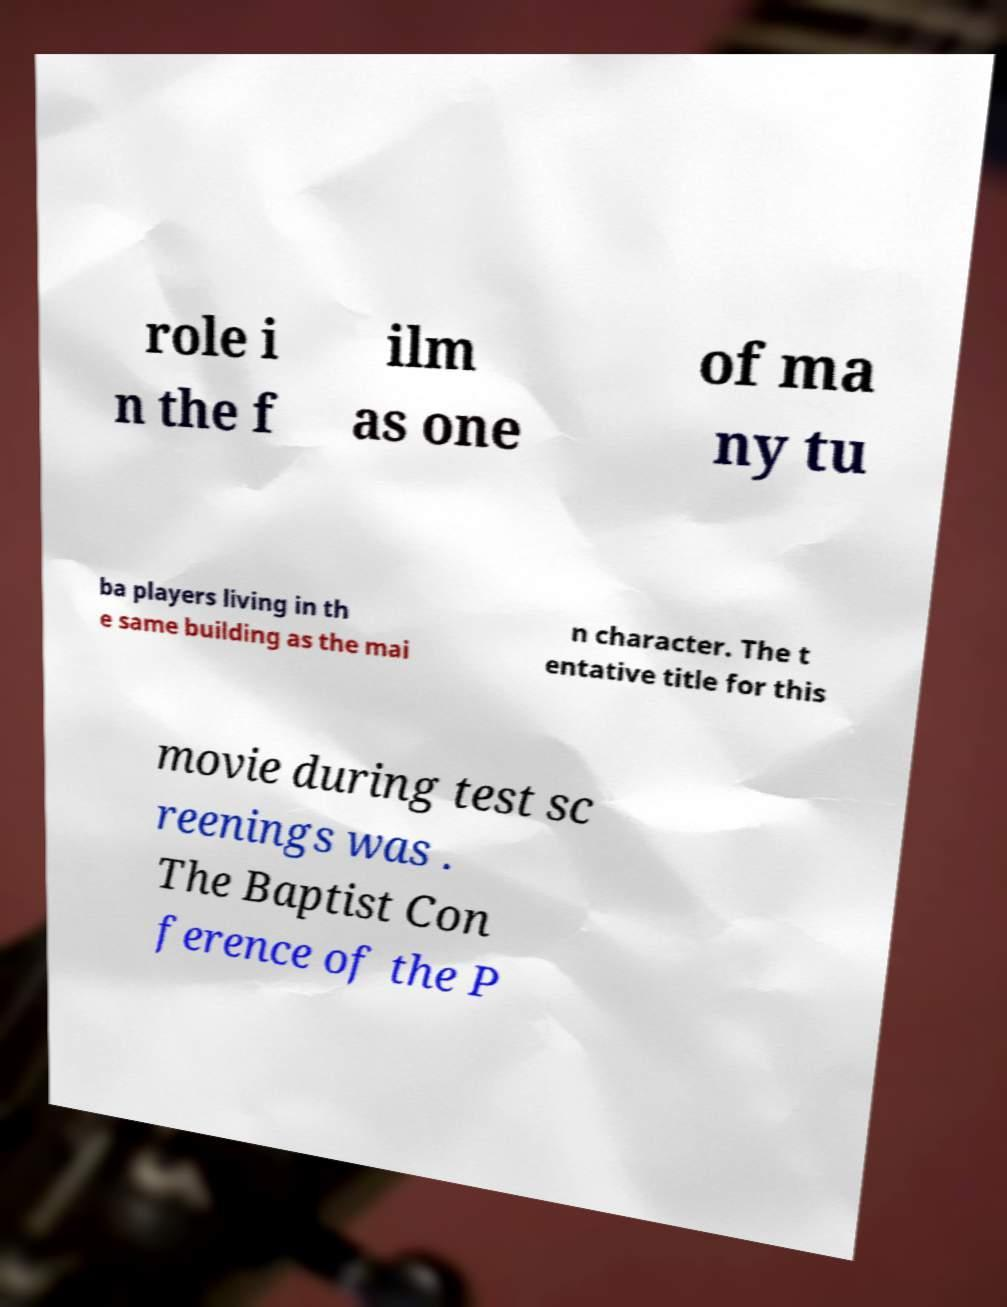There's text embedded in this image that I need extracted. Can you transcribe it verbatim? role i n the f ilm as one of ma ny tu ba players living in th e same building as the mai n character. The t entative title for this movie during test sc reenings was . The Baptist Con ference of the P 